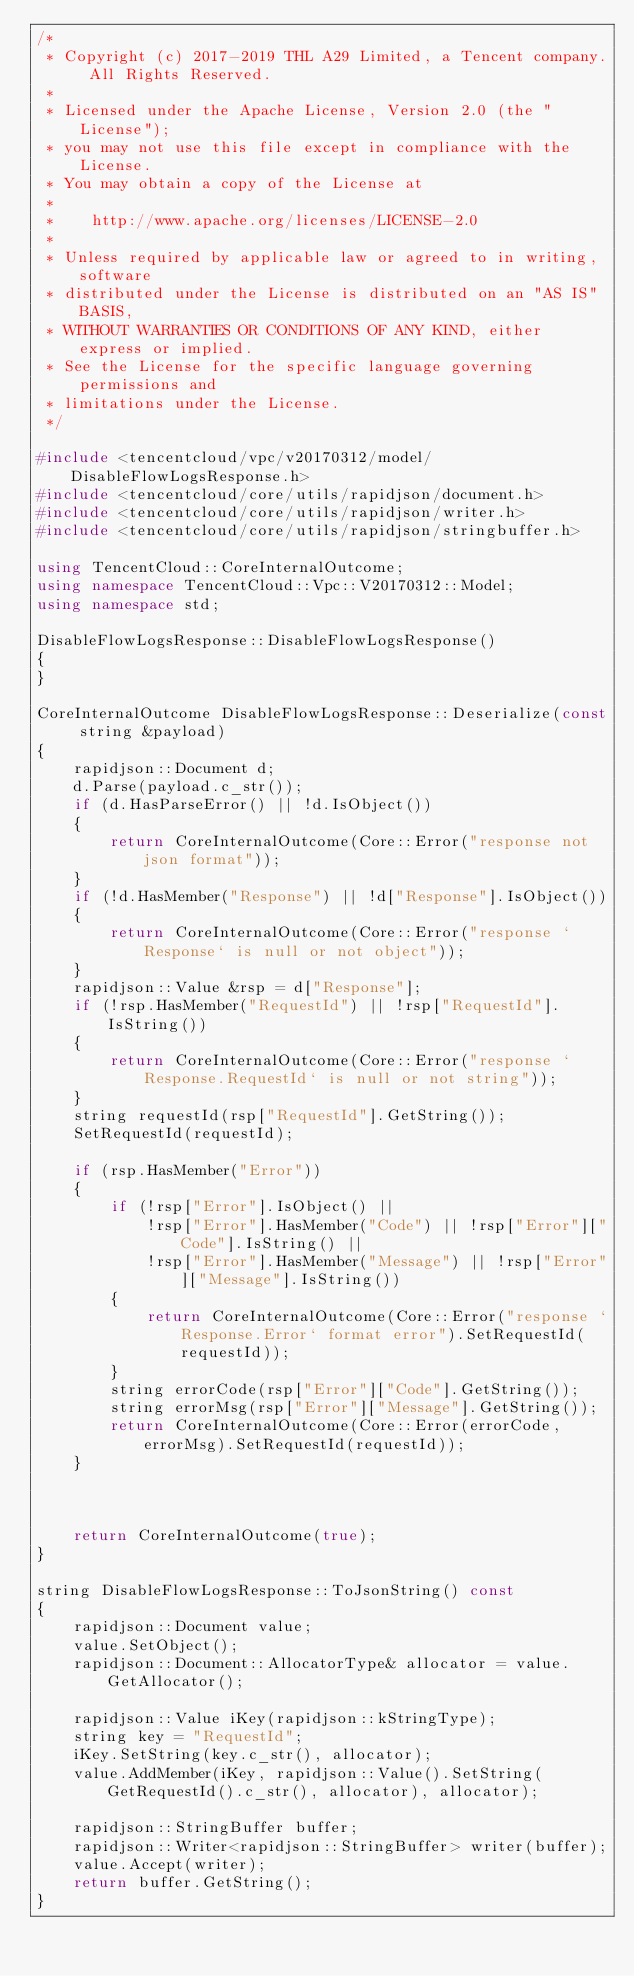<code> <loc_0><loc_0><loc_500><loc_500><_C++_>/*
 * Copyright (c) 2017-2019 THL A29 Limited, a Tencent company. All Rights Reserved.
 *
 * Licensed under the Apache License, Version 2.0 (the "License");
 * you may not use this file except in compliance with the License.
 * You may obtain a copy of the License at
 *
 *    http://www.apache.org/licenses/LICENSE-2.0
 *
 * Unless required by applicable law or agreed to in writing, software
 * distributed under the License is distributed on an "AS IS" BASIS,
 * WITHOUT WARRANTIES OR CONDITIONS OF ANY KIND, either express or implied.
 * See the License for the specific language governing permissions and
 * limitations under the License.
 */

#include <tencentcloud/vpc/v20170312/model/DisableFlowLogsResponse.h>
#include <tencentcloud/core/utils/rapidjson/document.h>
#include <tencentcloud/core/utils/rapidjson/writer.h>
#include <tencentcloud/core/utils/rapidjson/stringbuffer.h>

using TencentCloud::CoreInternalOutcome;
using namespace TencentCloud::Vpc::V20170312::Model;
using namespace std;

DisableFlowLogsResponse::DisableFlowLogsResponse()
{
}

CoreInternalOutcome DisableFlowLogsResponse::Deserialize(const string &payload)
{
    rapidjson::Document d;
    d.Parse(payload.c_str());
    if (d.HasParseError() || !d.IsObject())
    {
        return CoreInternalOutcome(Core::Error("response not json format"));
    }
    if (!d.HasMember("Response") || !d["Response"].IsObject())
    {
        return CoreInternalOutcome(Core::Error("response `Response` is null or not object"));
    }
    rapidjson::Value &rsp = d["Response"];
    if (!rsp.HasMember("RequestId") || !rsp["RequestId"].IsString())
    {
        return CoreInternalOutcome(Core::Error("response `Response.RequestId` is null or not string"));
    }
    string requestId(rsp["RequestId"].GetString());
    SetRequestId(requestId);

    if (rsp.HasMember("Error"))
    {
        if (!rsp["Error"].IsObject() ||
            !rsp["Error"].HasMember("Code") || !rsp["Error"]["Code"].IsString() ||
            !rsp["Error"].HasMember("Message") || !rsp["Error"]["Message"].IsString())
        {
            return CoreInternalOutcome(Core::Error("response `Response.Error` format error").SetRequestId(requestId));
        }
        string errorCode(rsp["Error"]["Code"].GetString());
        string errorMsg(rsp["Error"]["Message"].GetString());
        return CoreInternalOutcome(Core::Error(errorCode, errorMsg).SetRequestId(requestId));
    }



    return CoreInternalOutcome(true);
}

string DisableFlowLogsResponse::ToJsonString() const
{
    rapidjson::Document value;
    value.SetObject();
    rapidjson::Document::AllocatorType& allocator = value.GetAllocator();

    rapidjson::Value iKey(rapidjson::kStringType);
    string key = "RequestId";
    iKey.SetString(key.c_str(), allocator);
    value.AddMember(iKey, rapidjson::Value().SetString(GetRequestId().c_str(), allocator), allocator);
    
    rapidjson::StringBuffer buffer;
    rapidjson::Writer<rapidjson::StringBuffer> writer(buffer);
    value.Accept(writer);
    return buffer.GetString();
}



</code> 